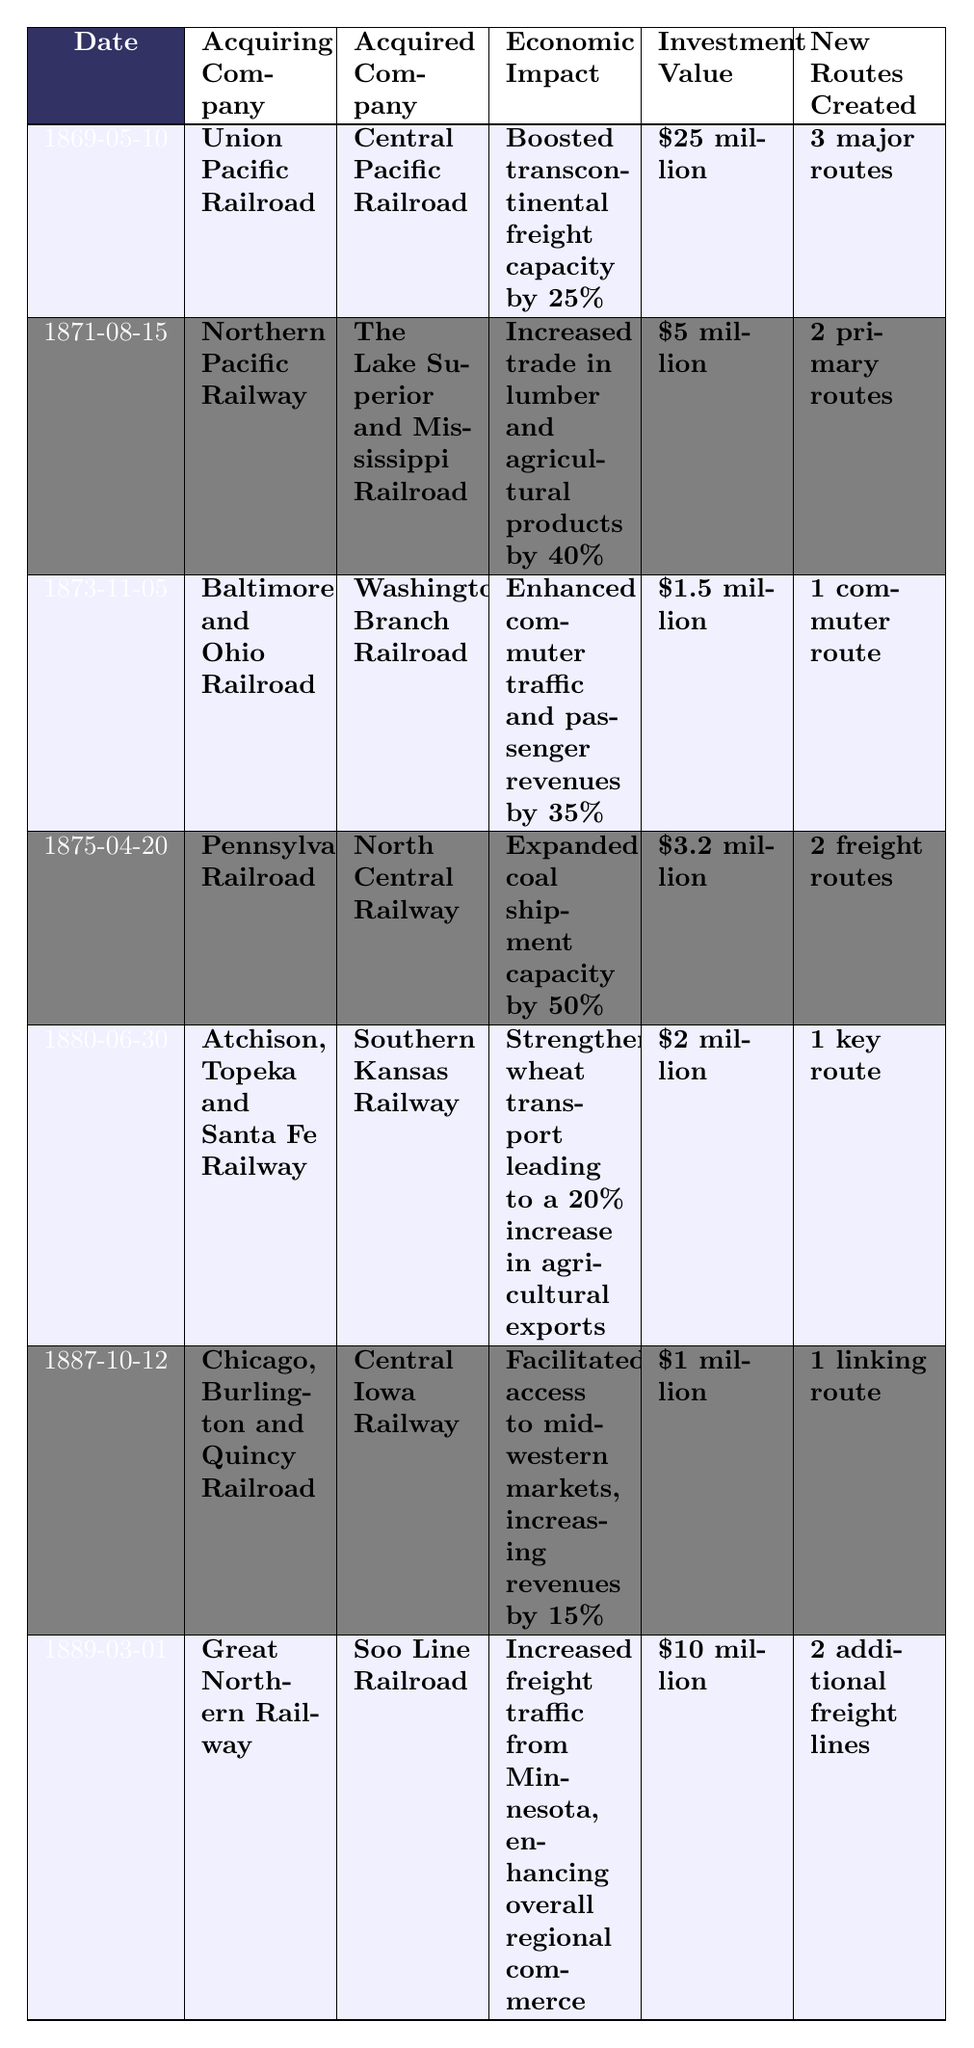What was the economic impact of the Union Pacific Railroad's acquisition of the Central Pacific Railroad? According to the table, the economic impact was a boost in transcontinental freight capacity by 25%.
Answer: Boosted transcontinental freight capacity by 25% How much was the investment value for the Pennsylvania Railroad's acquisition of the North Central Railway? The investment value listed in the table is $3.2 million.
Answer: $3.2 million Which railroad acquisition resulted in the largest economic impact? By reviewing the economic impacts listed, the acquisition with the largest impact is the Pennsylvania Railroad, with an expanded coal shipment capacity by 50%.
Answer: Expanded coal shipment capacity by 50% How many new routes were created by the acquisition of the Southern Kansas Railway by the Atchison, Topeka and Santa Fe Railway? The table indicates that 1 key route was created.
Answer: 1 key route What is the difference in investment value between the Great Northern Railway's acquisition and the Chicago, Burlington and Quincy Railroad's acquisition? The investment value of the Great Northern Railway's acquisition is $10 million, and for the Chicago, Burlington and Quincy Railroad, it is $1 million. The difference is $10 million - $1 million = $9 million.
Answer: $9 million Did any railroad acquisition increase trade in lumber and agricultural products by 40%? Yes, the Northern Pacific Railway's acquisition of The Lake Superior and Mississippi Railroad had this economic impact.
Answer: Yes Which railroad company saw an increase in agricultural exports due to a specific acquisition? The Atchison, Topeka and Santa Fe Railway saw a 20% increase in agricultural exports after acquiring the Southern Kansas Railway.
Answer: Atchison, Topeka and Santa Fe Railway What was the total number of new routes created across all acquisitions listed in the table? Adding the new routes: 3 + 2 + 1 + 2 + 1 + 1 + 2 = 12. Therefore, the total number of new routes created is 12.
Answer: 12 Which acquiring company had the lowest investment value, and what was that value? The company with the lowest investment value is the Chicago, Burlington and Quincy Railroad, with an investment of $1 million.
Answer: $1 million What percentage increase in revenues did the Chicago, Burlington and Quincy Railroad experience after its acquisition? The table states an increase of 15% in revenues as a result of this acquisition.
Answer: 15% 